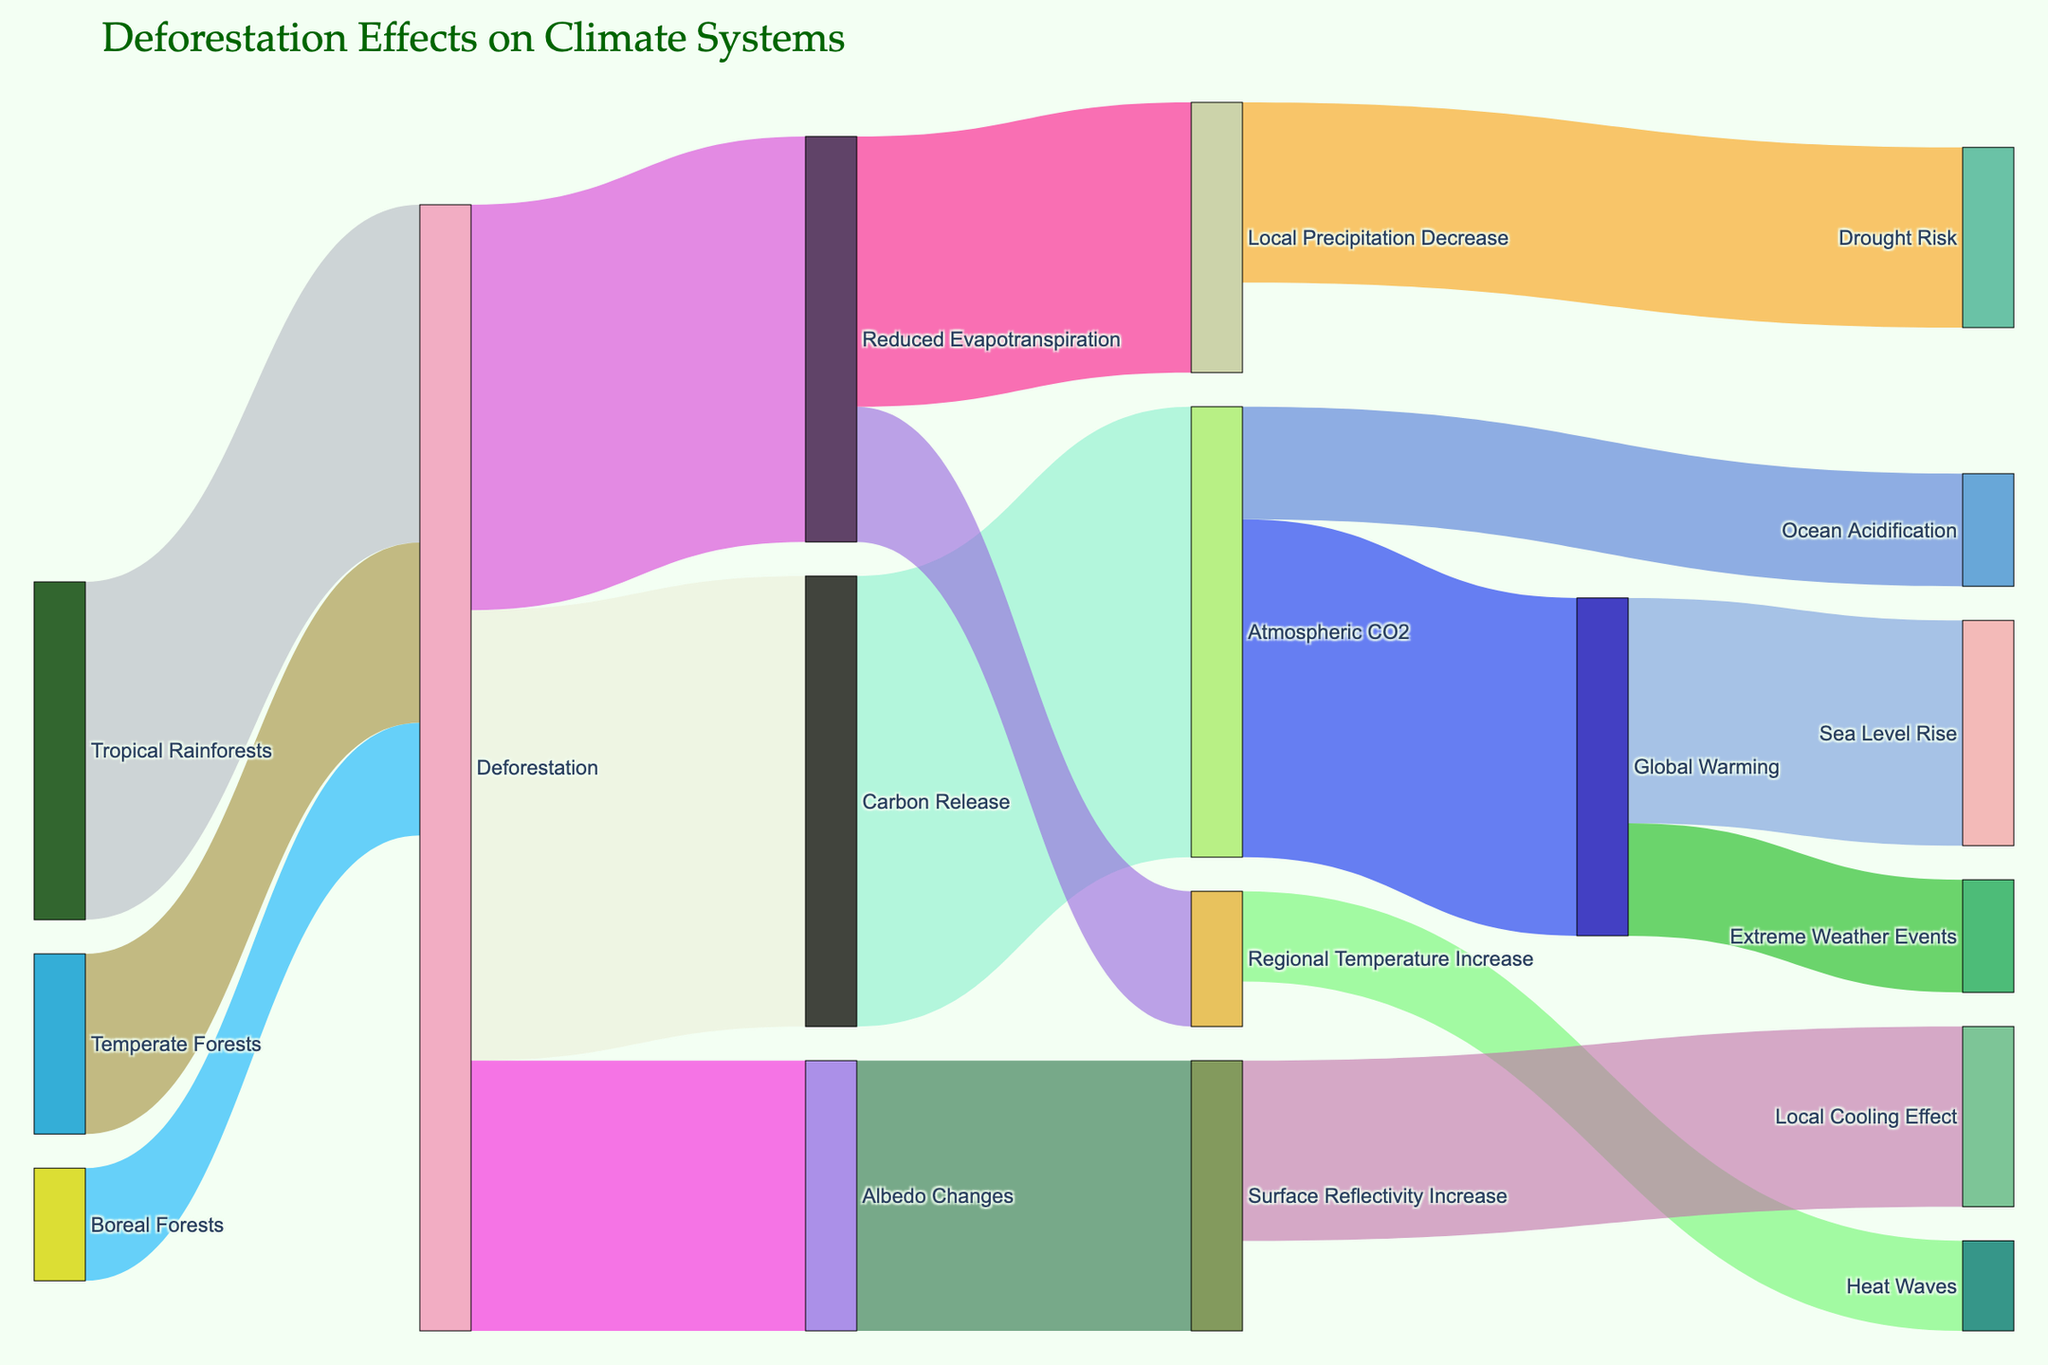What is the main title of the figure? The title is prominently displayed at the top of the figure.
Answer: Deforestation Effects on Climate Systems Which forest type contributes the most to deforestation? By comparing the values connecting each forest type to deforestation, the tropical rainforests have the highest value at 15.
Answer: Tropical Rainforests What is the total value of carbon release and reduced evapotranspiration due to deforestation? The value from deforestation to carbon release is 20, and the value to reduced evapotranspiration is 18. Summing these values: 20 + 18 = 38.
Answer: 38 Between the effects of atmospheric CO2, which impact has a higher value? Atmospheric CO2 leads to global warming (15) and ocean acidification (5). Comparing these values, global warming has a higher value.
Answer: Global Warming Which process contributes most to the increase in local cooling effect? The only path leading to a local cooling effect is from albedo changes with a value of 12.
Answer: Albedo Changes By what value does reduced evapotranspiration impact local precipitation decrease and regional temperature increase combined? Reduced evapotranspiration leads to a local precipitation decrease valued at 12 and a regional temperature increase valued at 6. Summing these: 12 + 6 = 18.
Answer: 18 What is the relationship between global warming and extreme weather events? A link from global warming to extreme weather events with a value of 5 indicates causation.
Answer: Global Warming causes Extreme Weather Events Which effect has the highest value stemming from deforestation? Comparing the values from deforestation to its effects, carbon release has the highest value of 20.
Answer: Carbon Release Can local precipitation decrease directly relate to heat waves? There is no direct link from local precipitation decrease to heat waves in the figure.
Answer: No How does surface reflectivity increase primarily affect the climate system? Surface reflectivity increase connects only to a local cooling effect with a value of 8.
Answer: Local Cooling Effect 